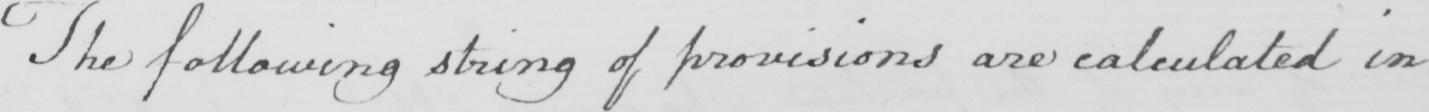Please transcribe the handwritten text in this image. The following string of provisions are calculated in 